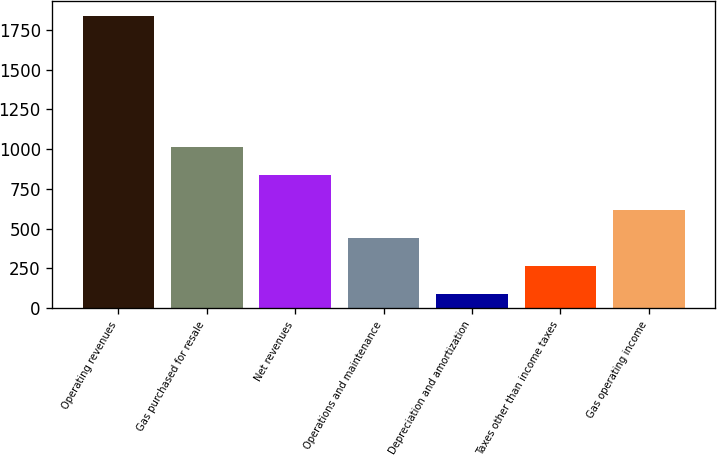Convert chart. <chart><loc_0><loc_0><loc_500><loc_500><bar_chart><fcel>Operating revenues<fcel>Gas purchased for resale<fcel>Net revenues<fcel>Operations and maintenance<fcel>Depreciation and amortization<fcel>Taxes other than income taxes<fcel>Gas operating income<nl><fcel>1839<fcel>1014.9<fcel>840<fcel>439.8<fcel>90<fcel>264.9<fcel>614.7<nl></chart> 